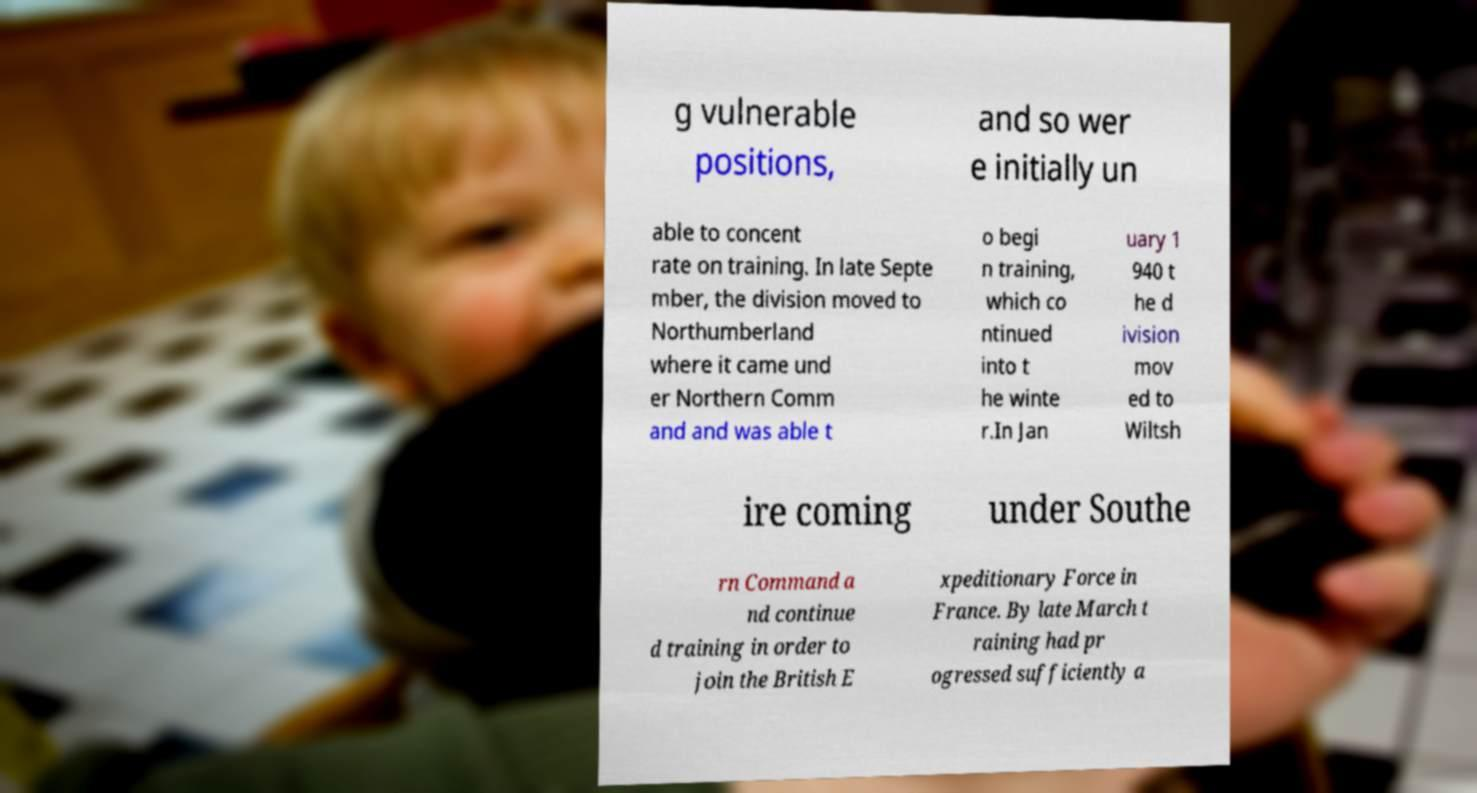What messages or text are displayed in this image? I need them in a readable, typed format. g vulnerable positions, and so wer e initially un able to concent rate on training. In late Septe mber, the division moved to Northumberland where it came und er Northern Comm and and was able t o begi n training, which co ntinued into t he winte r.In Jan uary 1 940 t he d ivision mov ed to Wiltsh ire coming under Southe rn Command a nd continue d training in order to join the British E xpeditionary Force in France. By late March t raining had pr ogressed sufficiently a 